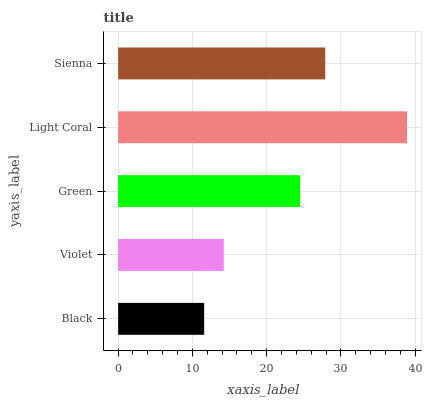Is Black the minimum?
Answer yes or no. Yes. Is Light Coral the maximum?
Answer yes or no. Yes. Is Violet the minimum?
Answer yes or no. No. Is Violet the maximum?
Answer yes or no. No. Is Violet greater than Black?
Answer yes or no. Yes. Is Black less than Violet?
Answer yes or no. Yes. Is Black greater than Violet?
Answer yes or no. No. Is Violet less than Black?
Answer yes or no. No. Is Green the high median?
Answer yes or no. Yes. Is Green the low median?
Answer yes or no. Yes. Is Light Coral the high median?
Answer yes or no. No. Is Violet the low median?
Answer yes or no. No. 